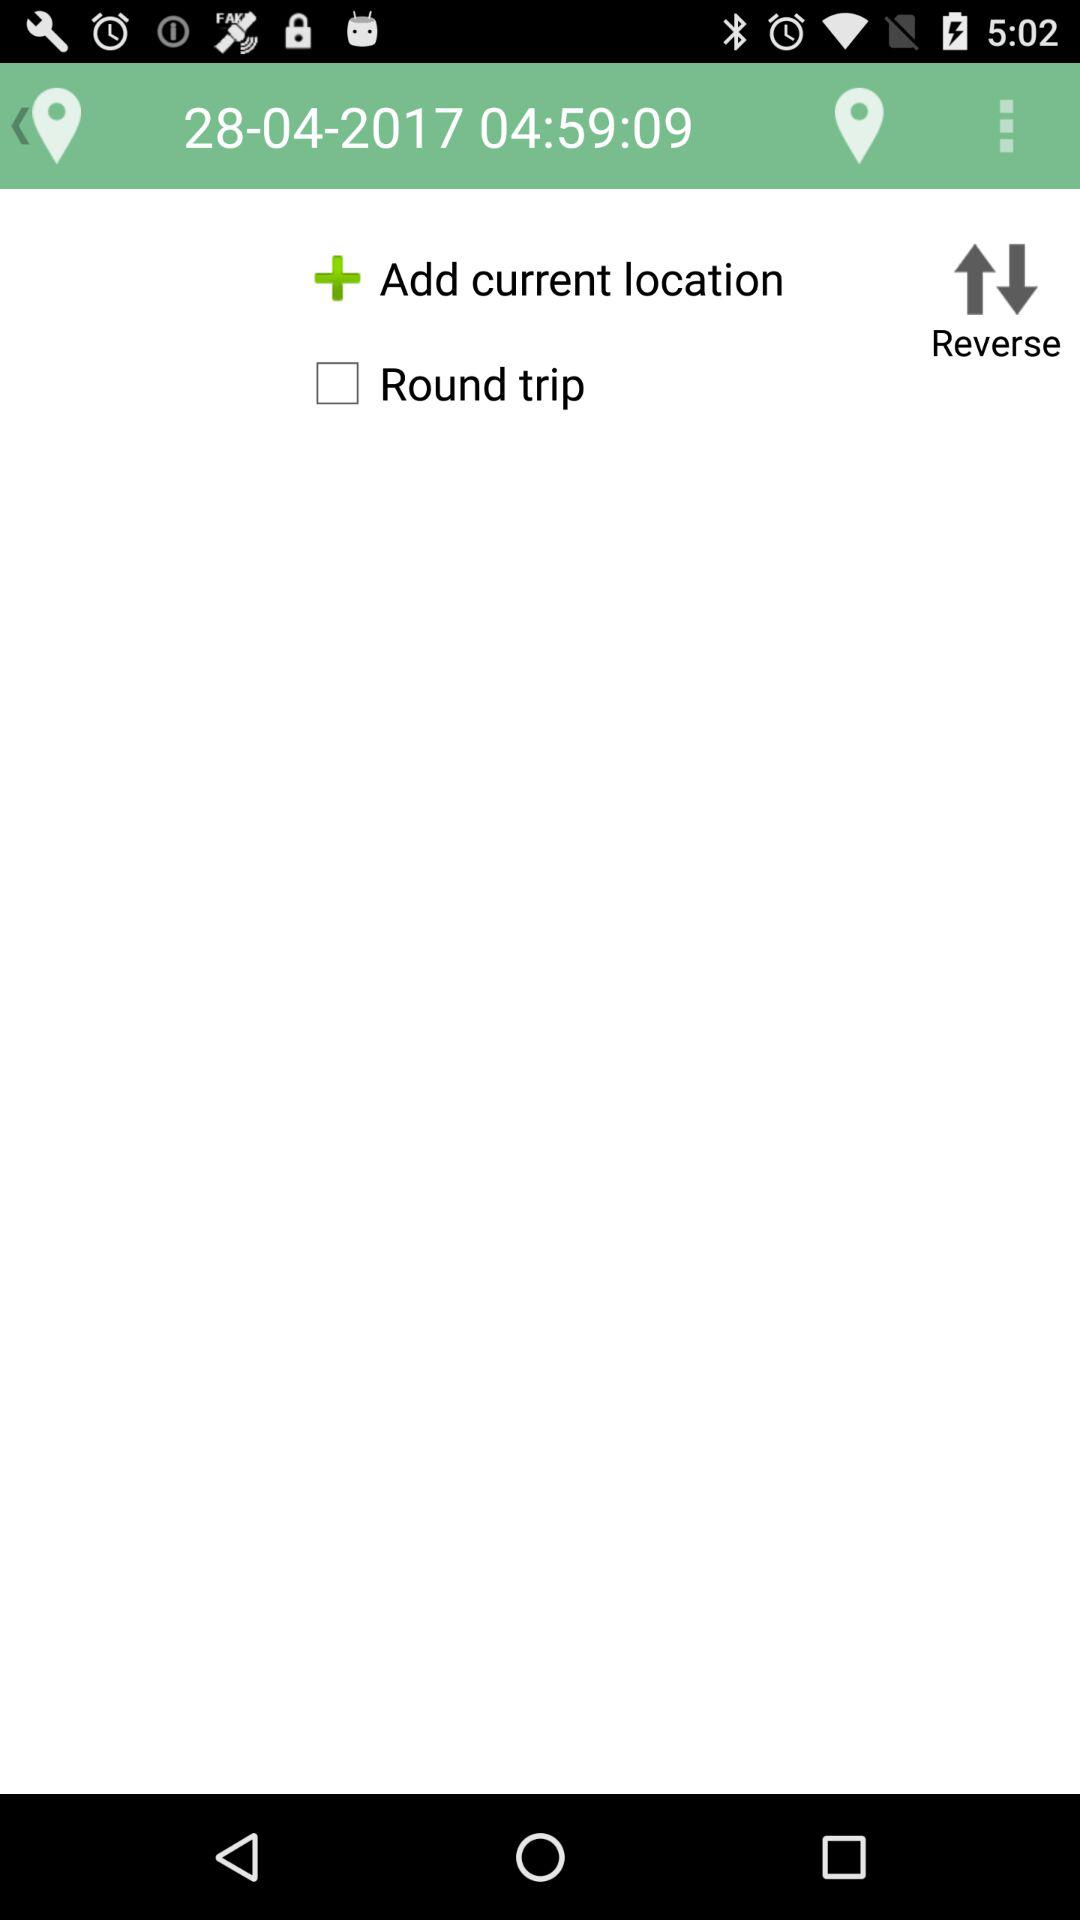What is the date? The date is April 28, 2017. 